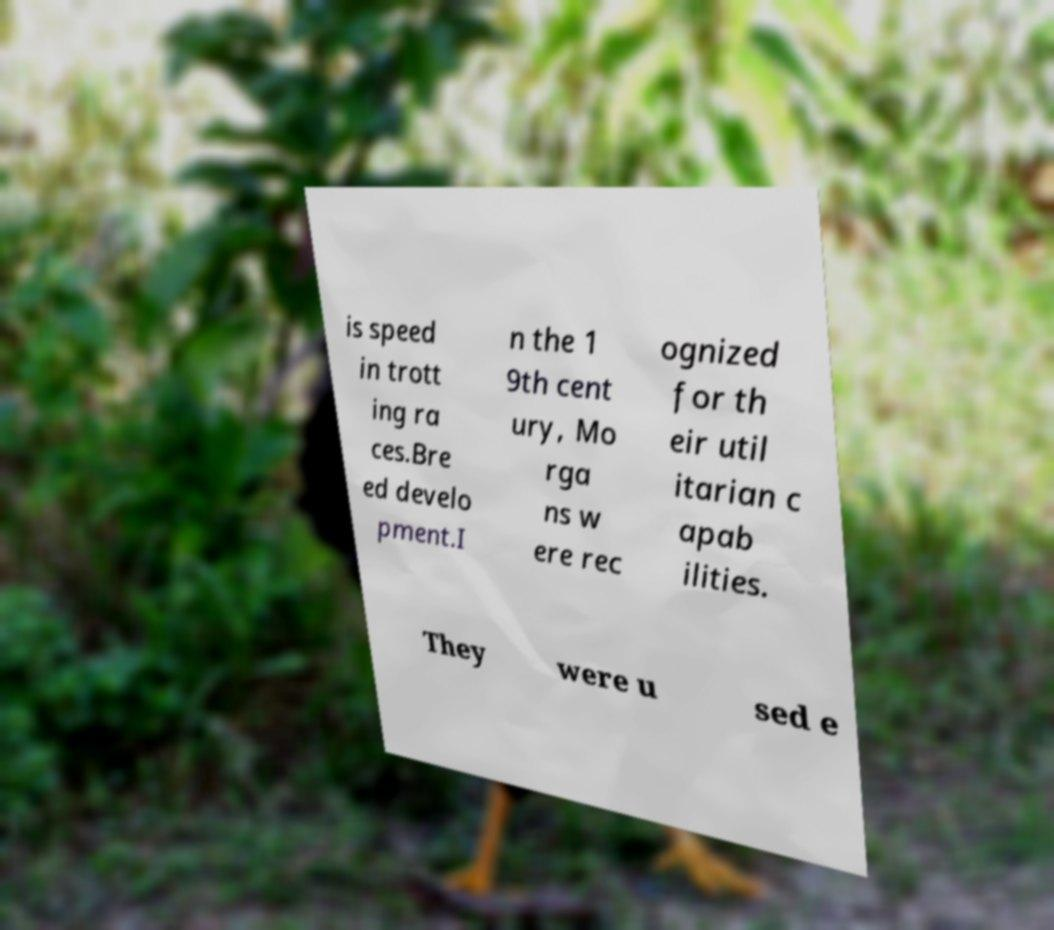For documentation purposes, I need the text within this image transcribed. Could you provide that? is speed in trott ing ra ces.Bre ed develo pment.I n the 1 9th cent ury, Mo rga ns w ere rec ognized for th eir util itarian c apab ilities. They were u sed e 